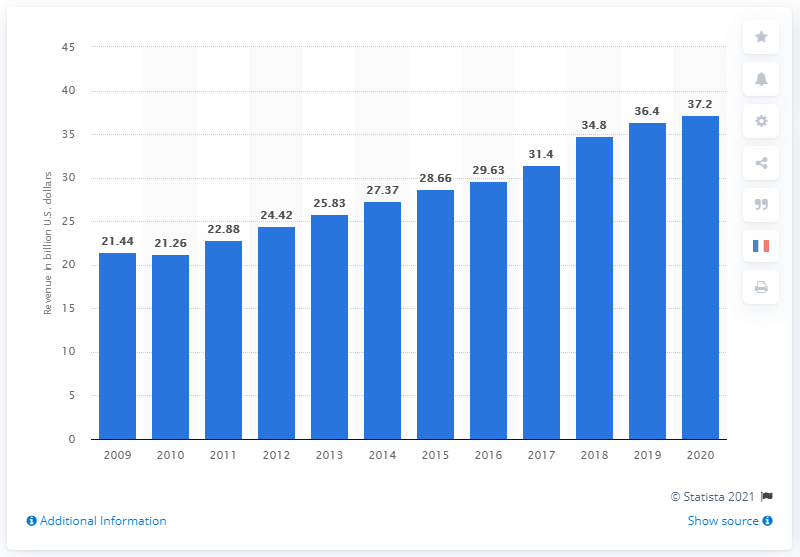List a handful of essential elements in this visual. The previous year's revenue for EY was 34.8 billion USD. According to the fiscal year of 2019, EY generated $36.4 million dollars. 